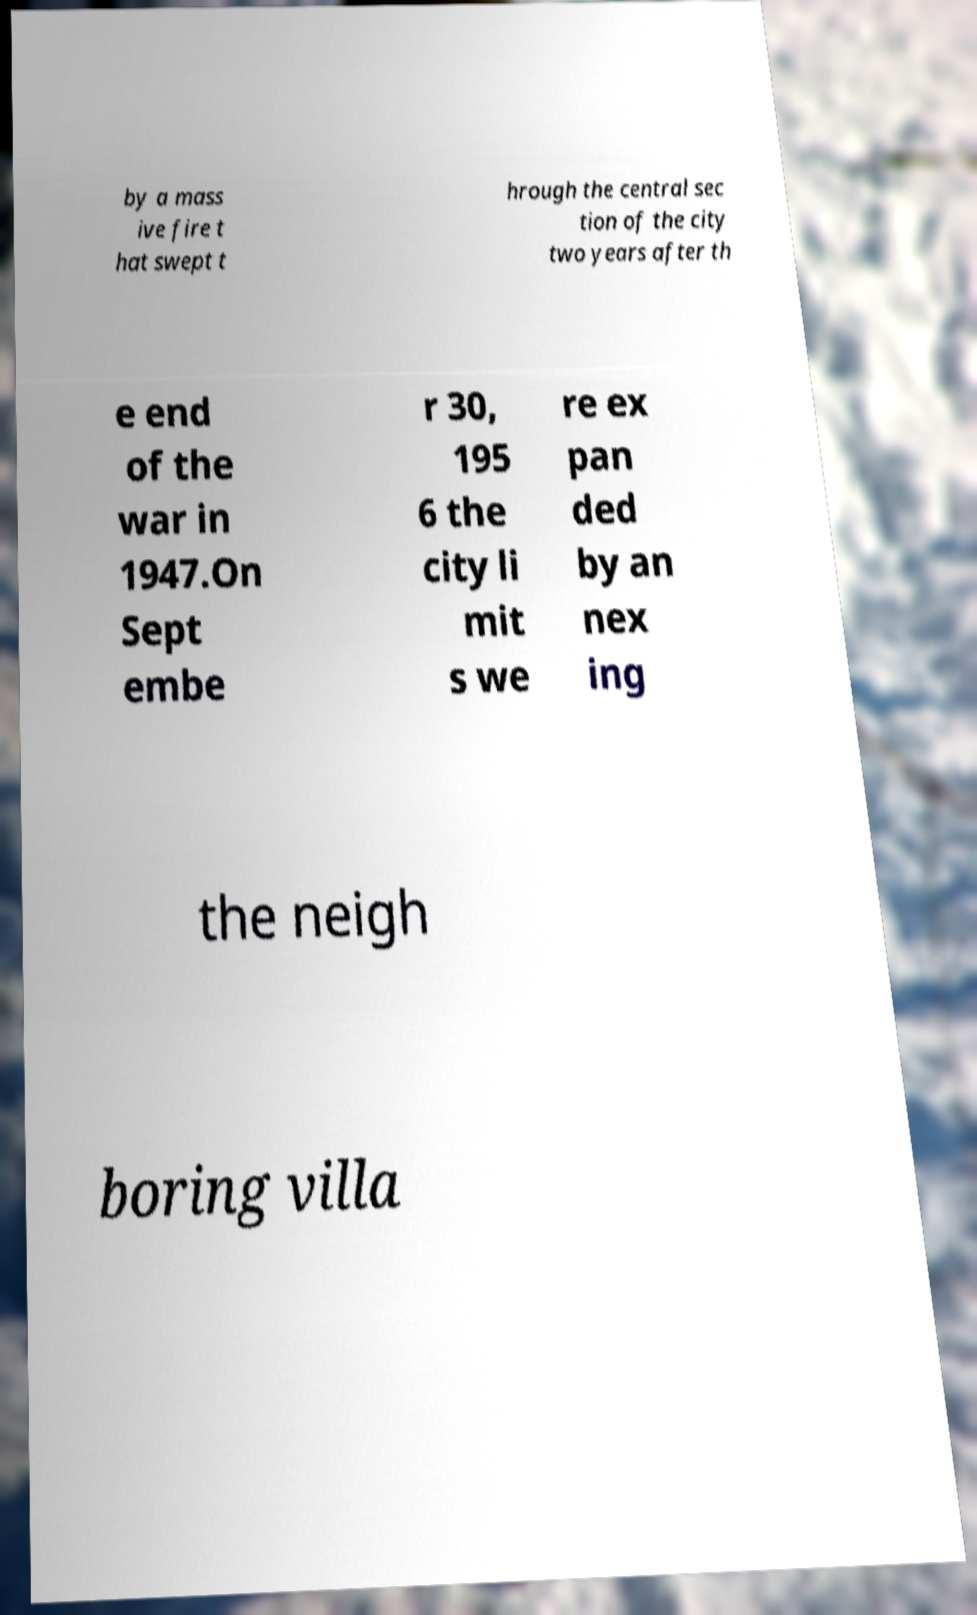For documentation purposes, I need the text within this image transcribed. Could you provide that? by a mass ive fire t hat swept t hrough the central sec tion of the city two years after th e end of the war in 1947.On Sept embe r 30, 195 6 the city li mit s we re ex pan ded by an nex ing the neigh boring villa 